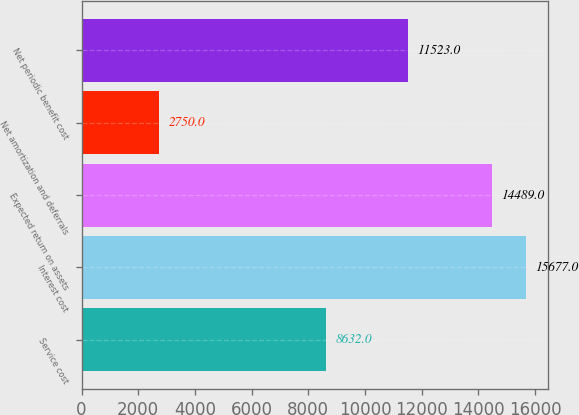<chart> <loc_0><loc_0><loc_500><loc_500><bar_chart><fcel>Service cost<fcel>Interest cost<fcel>Expected return on assets<fcel>Net amortization and deferrals<fcel>Net periodic benefit cost<nl><fcel>8632<fcel>15677<fcel>14489<fcel>2750<fcel>11523<nl></chart> 